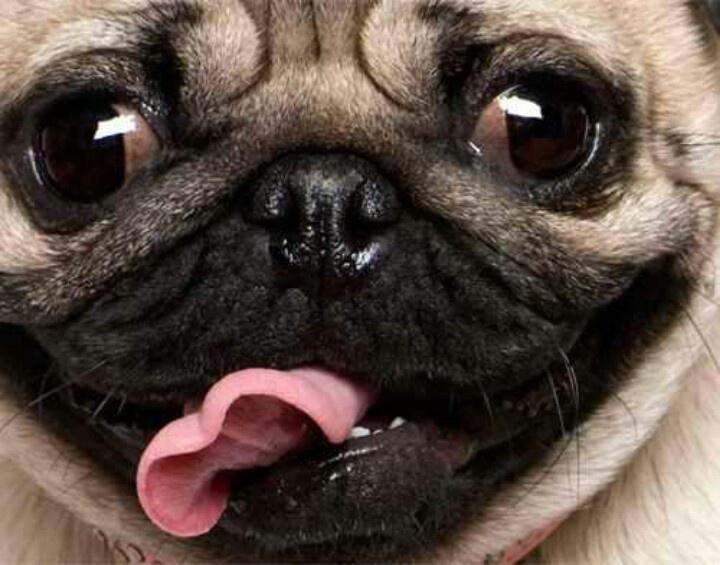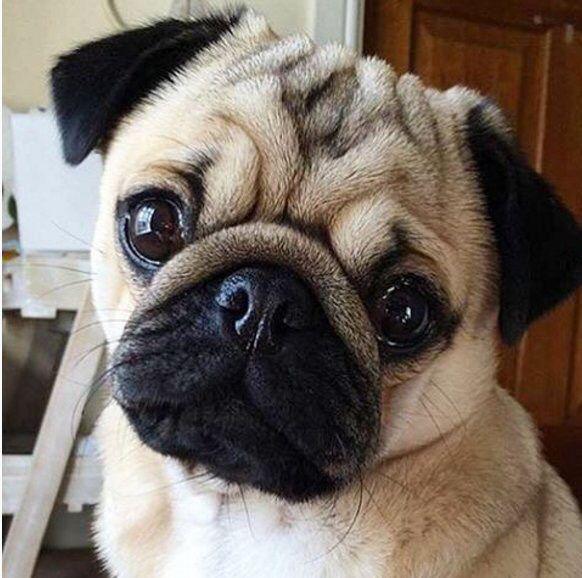The first image is the image on the left, the second image is the image on the right. Analyze the images presented: Is the assertion "Each image features one camera-gazing buff-beige pug with a dark muzzle, and one pug has its tongue sticking out." valid? Answer yes or no. Yes. The first image is the image on the left, the second image is the image on the right. Examine the images to the left and right. Is the description "Both images show a single pug and in one it has its tongue sticking out." accurate? Answer yes or no. Yes. 